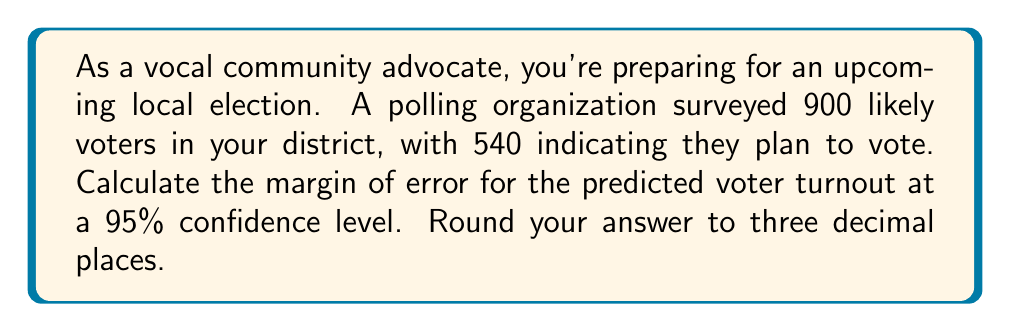Show me your answer to this math problem. To calculate the margin of error for this voter turnout prediction, we'll follow these steps:

1. Identify the components:
   - Sample size (n) = 900
   - Sample proportion (p̂) = 540 / 900 = 0.6
   - Confidence level = 95% (z-score = 1.96)

2. Use the margin of error formula:
   $$ \text{Margin of Error} = z \sqrt{\frac{p̂(1-p̂)}{n}} $$

3. Plug in the values:
   $$ \text{Margin of Error} = 1.96 \sqrt{\frac{0.6(1-0.6)}{900}} $$

4. Simplify:
   $$ \text{Margin of Error} = 1.96 \sqrt{\frac{0.6(0.4)}{900}} = 1.96 \sqrt{\frac{0.24}{900}} $$

5. Calculate:
   $$ \text{Margin of Error} = 1.96 \sqrt{0.000267} \approx 1.96 (0.0163) \approx 0.03195 $$

6. Round to three decimal places:
   $$ \text{Margin of Error} \approx 0.032 \text{ or } 3.2\% $$

This means that we can be 95% confident that the true population proportion of voters planning to vote is within ±3.2% of the sample proportion of 60%.
Answer: 0.032 or 3.2% 